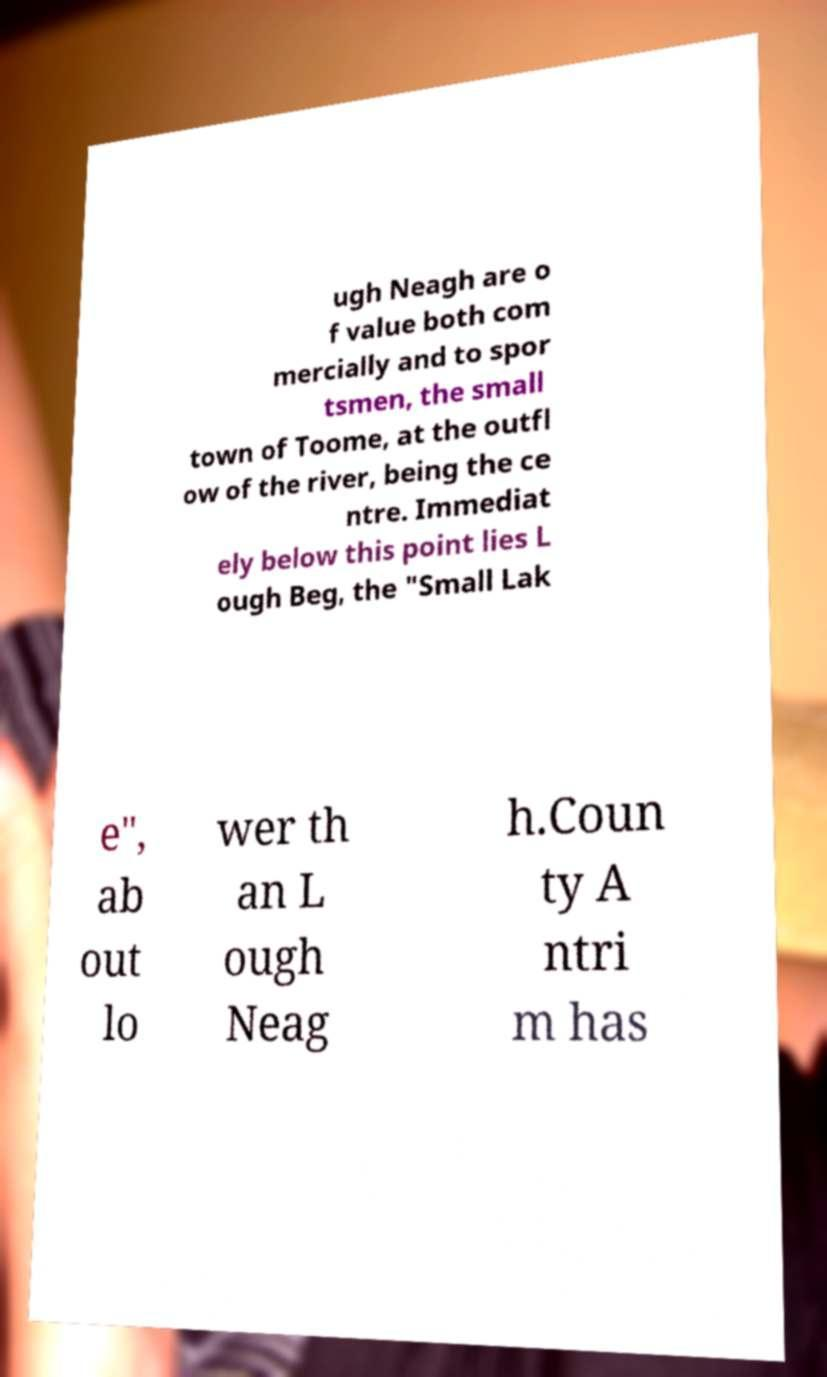Please read and relay the text visible in this image. What does it say? ugh Neagh are o f value both com mercially and to spor tsmen, the small town of Toome, at the outfl ow of the river, being the ce ntre. Immediat ely below this point lies L ough Beg, the "Small Lak e", ab out lo wer th an L ough Neag h.Coun ty A ntri m has 